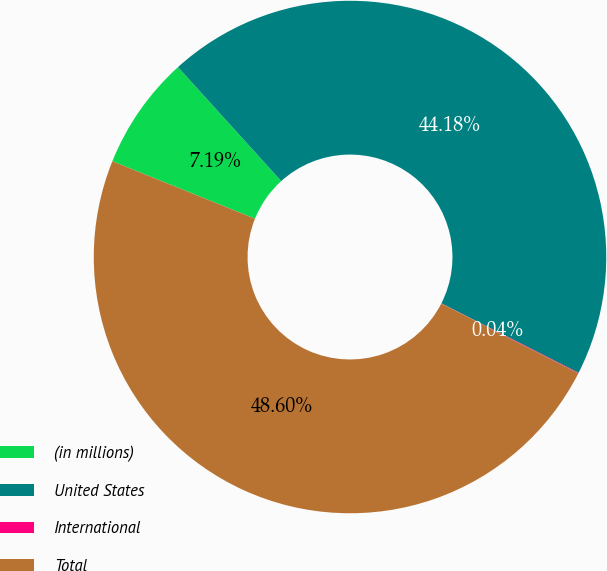Convert chart. <chart><loc_0><loc_0><loc_500><loc_500><pie_chart><fcel>(in millions)<fcel>United States<fcel>International<fcel>Total<nl><fcel>7.19%<fcel>44.18%<fcel>0.04%<fcel>48.6%<nl></chart> 